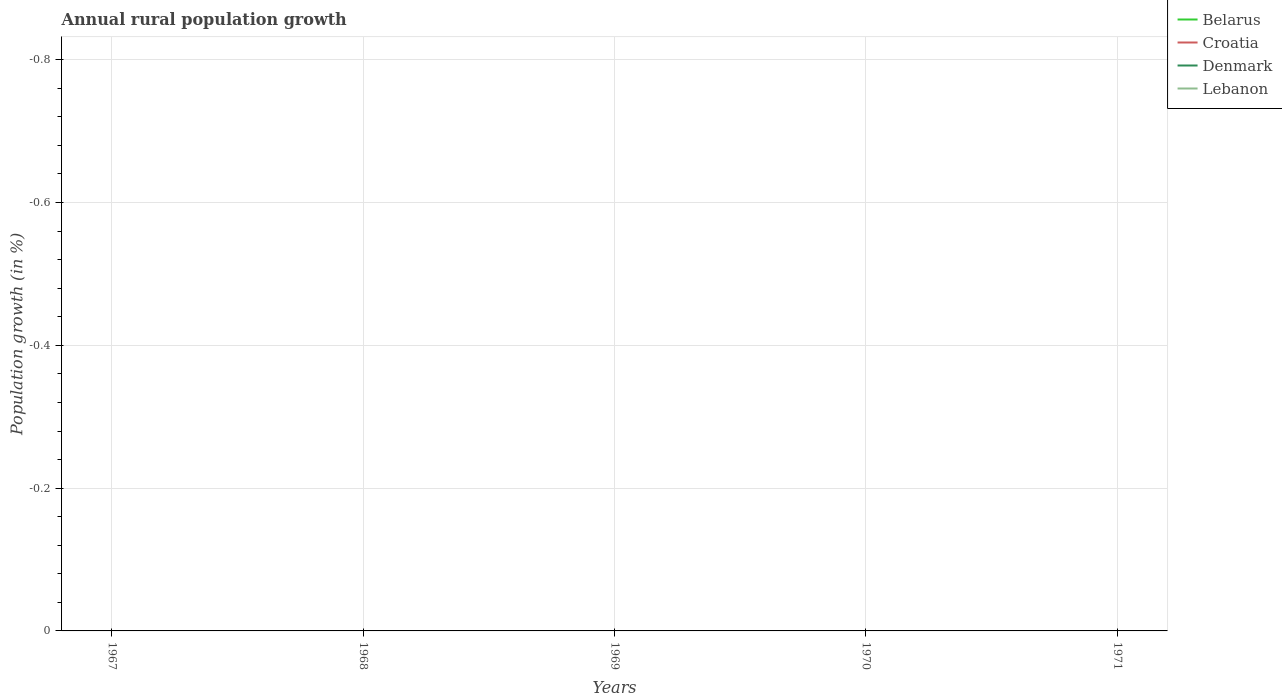Does the line corresponding to Denmark intersect with the line corresponding to Croatia?
Ensure brevity in your answer.  No. Across all years, what is the maximum percentage of rural population growth in Lebanon?
Provide a short and direct response. 0. Is the percentage of rural population growth in Croatia strictly greater than the percentage of rural population growth in Denmark over the years?
Offer a terse response. No. How many years are there in the graph?
Ensure brevity in your answer.  5. What is the difference between two consecutive major ticks on the Y-axis?
Your answer should be compact. 0.2. Are the values on the major ticks of Y-axis written in scientific E-notation?
Provide a succinct answer. No. Does the graph contain grids?
Your answer should be compact. Yes. Where does the legend appear in the graph?
Your answer should be very brief. Top right. How are the legend labels stacked?
Keep it short and to the point. Vertical. What is the title of the graph?
Your answer should be very brief. Annual rural population growth. Does "North America" appear as one of the legend labels in the graph?
Give a very brief answer. No. What is the label or title of the X-axis?
Your answer should be compact. Years. What is the label or title of the Y-axis?
Provide a short and direct response. Population growth (in %). What is the Population growth (in %) of Croatia in 1967?
Provide a short and direct response. 0. What is the Population growth (in %) in Denmark in 1967?
Offer a terse response. 0. What is the Population growth (in %) of Croatia in 1968?
Offer a terse response. 0. What is the Population growth (in %) of Denmark in 1968?
Your answer should be compact. 0. What is the Population growth (in %) of Belarus in 1969?
Your answer should be compact. 0. What is the Population growth (in %) in Croatia in 1969?
Keep it short and to the point. 0. What is the Population growth (in %) in Belarus in 1970?
Your answer should be compact. 0. What is the Population growth (in %) of Lebanon in 1970?
Give a very brief answer. 0. What is the Population growth (in %) in Belarus in 1971?
Ensure brevity in your answer.  0. What is the Population growth (in %) of Croatia in 1971?
Your answer should be very brief. 0. What is the Population growth (in %) in Lebanon in 1971?
Offer a very short reply. 0. What is the total Population growth (in %) of Croatia in the graph?
Your response must be concise. 0. What is the total Population growth (in %) in Denmark in the graph?
Provide a short and direct response. 0. What is the total Population growth (in %) of Lebanon in the graph?
Your answer should be compact. 0. What is the average Population growth (in %) of Belarus per year?
Keep it short and to the point. 0. What is the average Population growth (in %) of Croatia per year?
Provide a succinct answer. 0. What is the average Population growth (in %) in Denmark per year?
Keep it short and to the point. 0. What is the average Population growth (in %) of Lebanon per year?
Offer a terse response. 0. 